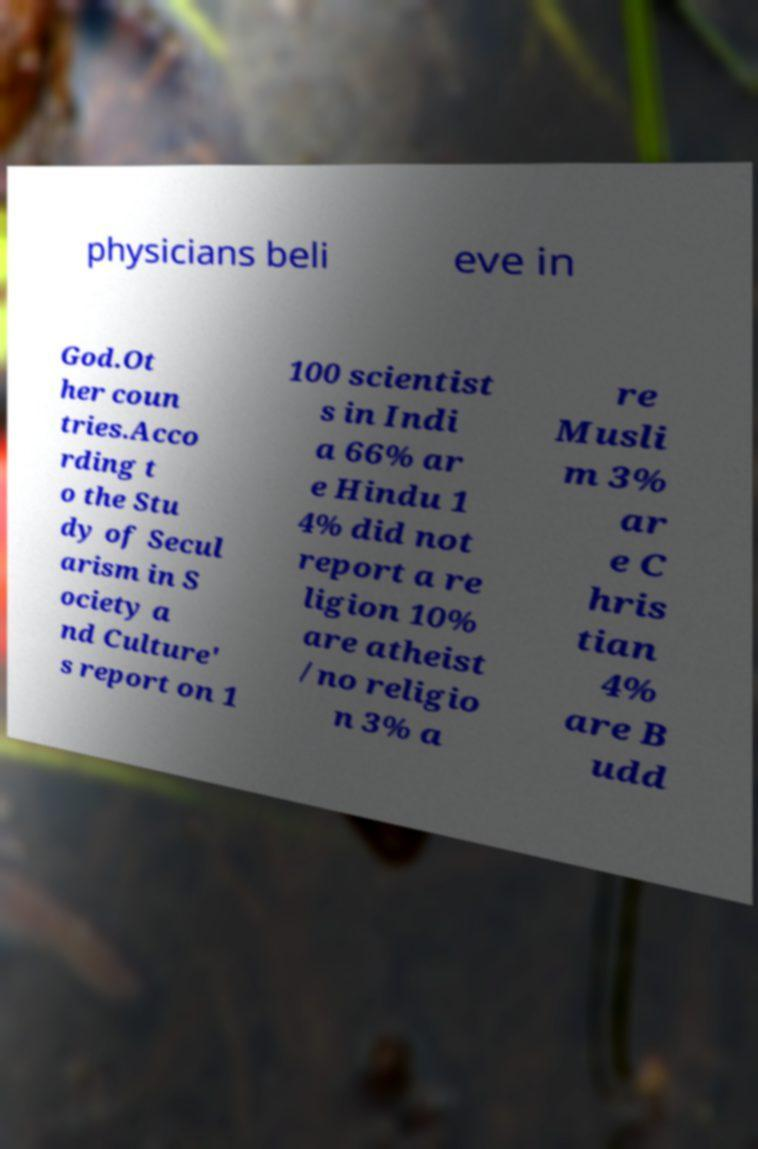Please identify and transcribe the text found in this image. physicians beli eve in God.Ot her coun tries.Acco rding t o the Stu dy of Secul arism in S ociety a nd Culture' s report on 1 100 scientist s in Indi a 66% ar e Hindu 1 4% did not report a re ligion 10% are atheist /no religio n 3% a re Musli m 3% ar e C hris tian 4% are B udd 